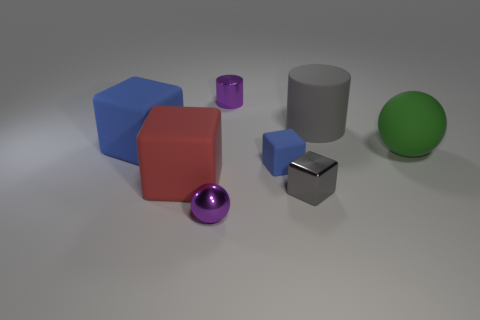What materials are the objects made of? The objects appear to have different materials. The large red and blue objects look like they're made of a matte plastic, the smaller purple and pink objects could be rubber due to their shinier appearance, the gray object has a metallic finish, and the green sphere might also be plastic but with a smoother, shinier finish. 